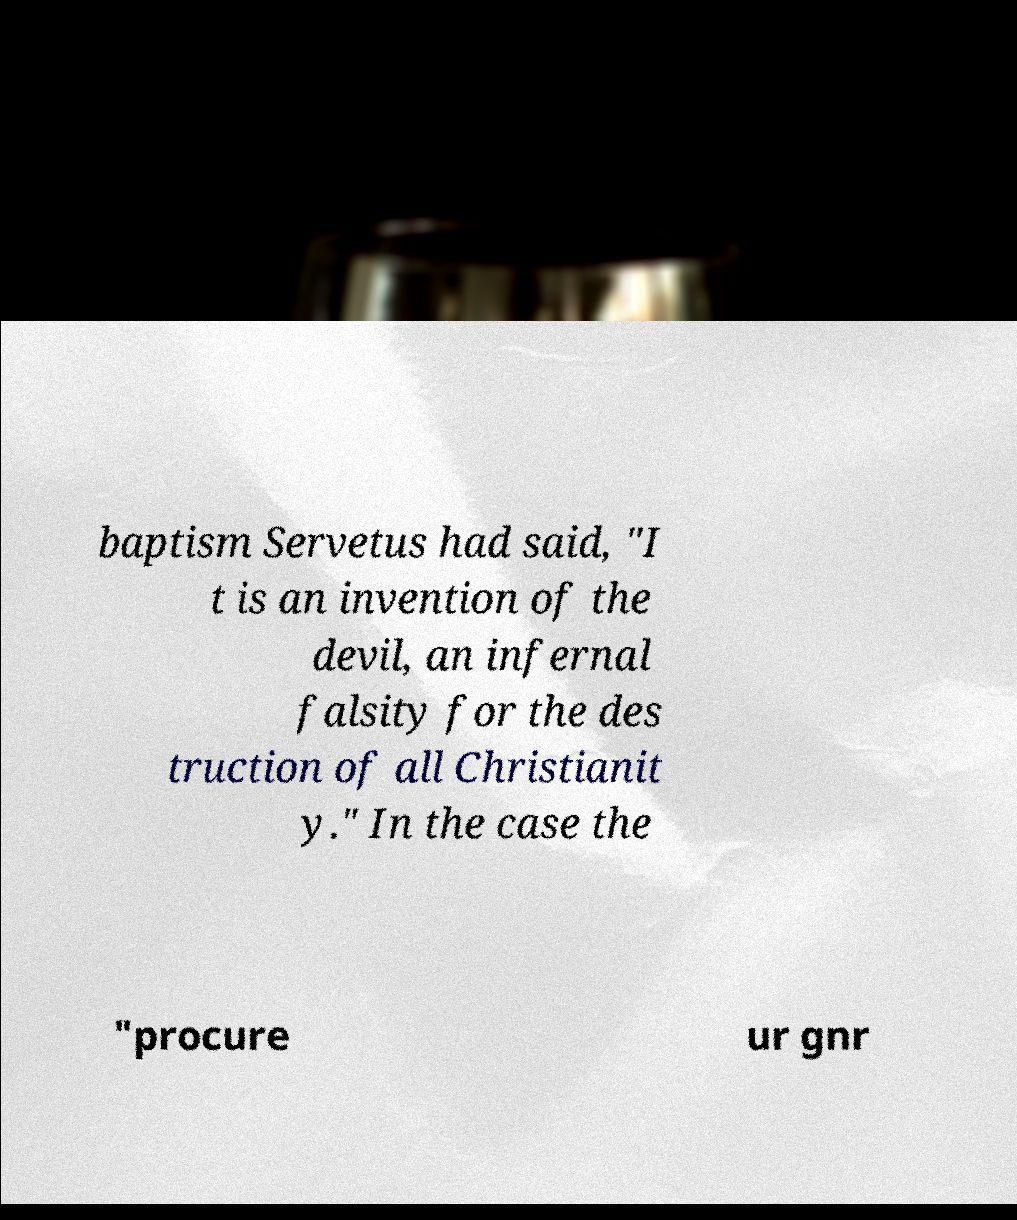There's text embedded in this image that I need extracted. Can you transcribe it verbatim? baptism Servetus had said, "I t is an invention of the devil, an infernal falsity for the des truction of all Christianit y." In the case the "procure ur gnr 